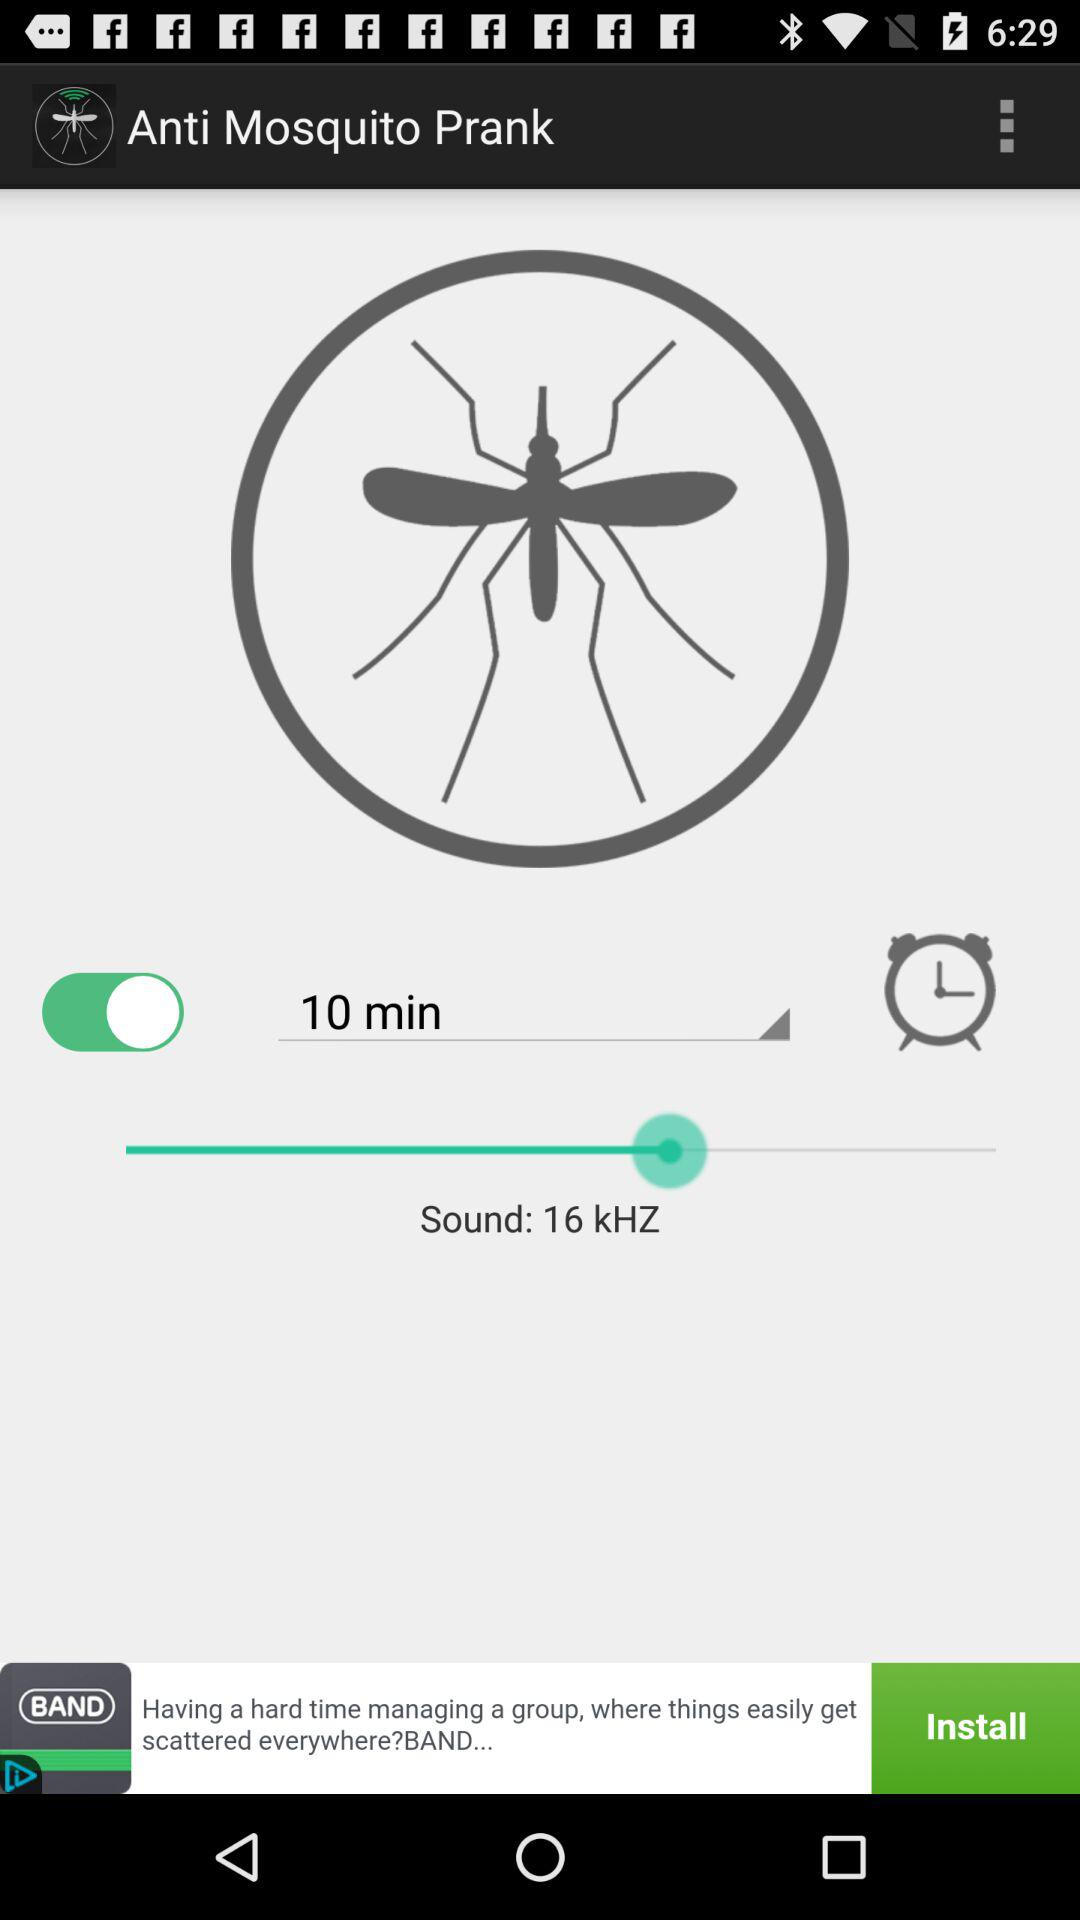What is the selected time duration? The selected time duration is 10 minutes. 